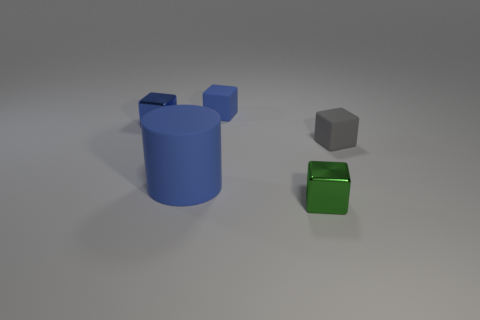What could be the function of these objects in a real-world setting? These objects might represent items in a graphics render for a 3D modeling software. The blue cylinder can be a container, the gray cube a placeholder for a larger structure in a design, and the green cube could serve as a decorative element or a stand-in for electronic equipment. 